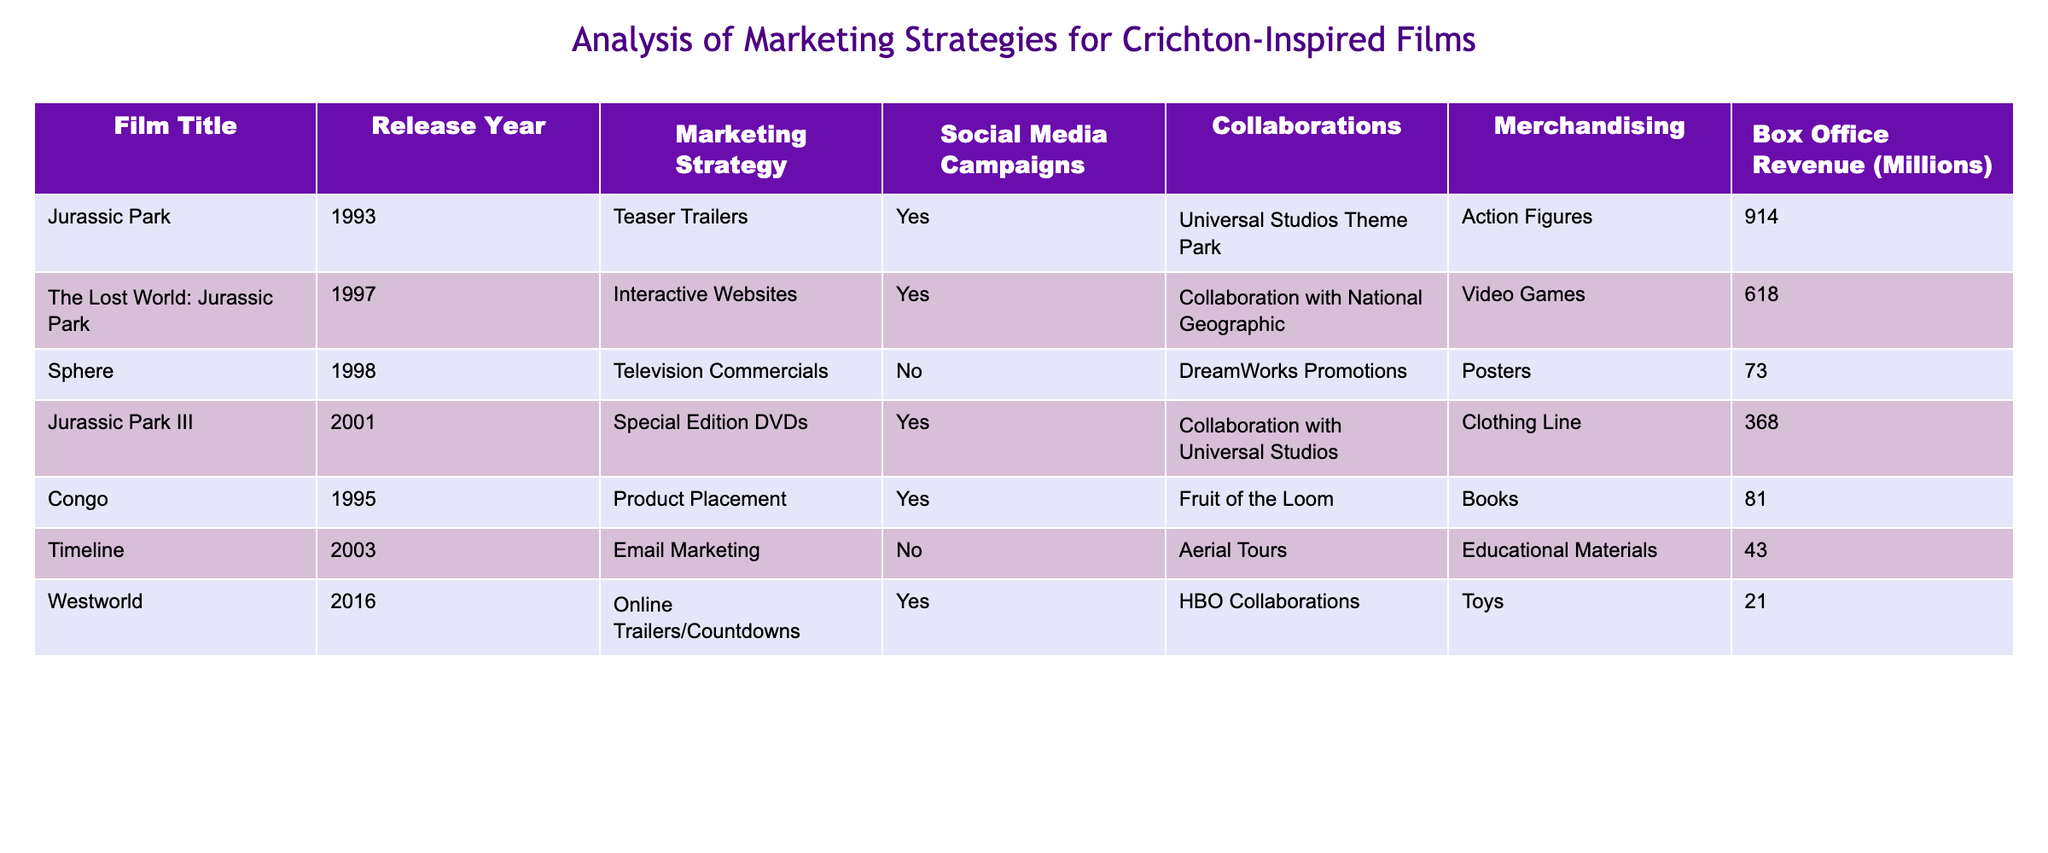What marketing strategy was used for the film "Jurassic Park"? The table indicates that "Jurassic Park" employed "Teaser Trailers" as its marketing strategy.
Answer: Teaser Trailers Which film collaboration involved National Geographic? According to the table, "The Lost World: Jurassic Park" had a collaboration with National Geographic.
Answer: The Lost World: Jurassic Park What is the box office revenue for "Timeline"? The table shows that "Timeline" had a box office revenue of 43 million dollars.
Answer: 43 What was the total box office revenue of the films that used "Yes" for Social Media Campaigns? We identify the films with "Yes" for Social Media Campaigns: "Jurassic Park" (914), "The Lost World: Jurassic Park" (618), "Jurassic Park III" (368), and "Westworld" (21). Adding these gives 914 + 618 + 368 + 21 = 1921 million.
Answer: 1921 Is there any film that used "Product Placement" as a marketing strategy? The data shows that "Congo" used "Product Placement" as a marketing strategy, confirming that there is at least one film that employed this tactic.
Answer: Yes Which marketing strategy had the lowest box office revenue among films that utilized "Collaborations"? The films that utilized Collaborations are "Jurassic Park III" (368), "Congo" (81), and "Westworld" (21). The one with the lowest box office revenue is "Westworld" at 21 million.
Answer: Westworld Was "Sphere" successful in terms of box office compared to "Westworld"? The box office revenue for "Sphere" is 73 million, while "Westworld" is 21 million. Therefore, "Sphere" was more successful since 73 > 21.
Answer: Yes How many films had a box office revenue greater than 100 million? The films with box office revenues greater than 100 million are "Jurassic Park" (914), "The Lost World: Jurassic Park" (618), "Jurassic Park III" (368). So there are three films in total.
Answer: 3 What is the average box office revenue of the films that did not run social media campaigns? The films without social media campaigns are "Sphere" (73), "Timeline" (43), and "Westworld" (21). Their total revenue is 73 + 43 + 21 = 137 million. The average is 137 / 3 = 45.67 million.
Answer: 45.67 